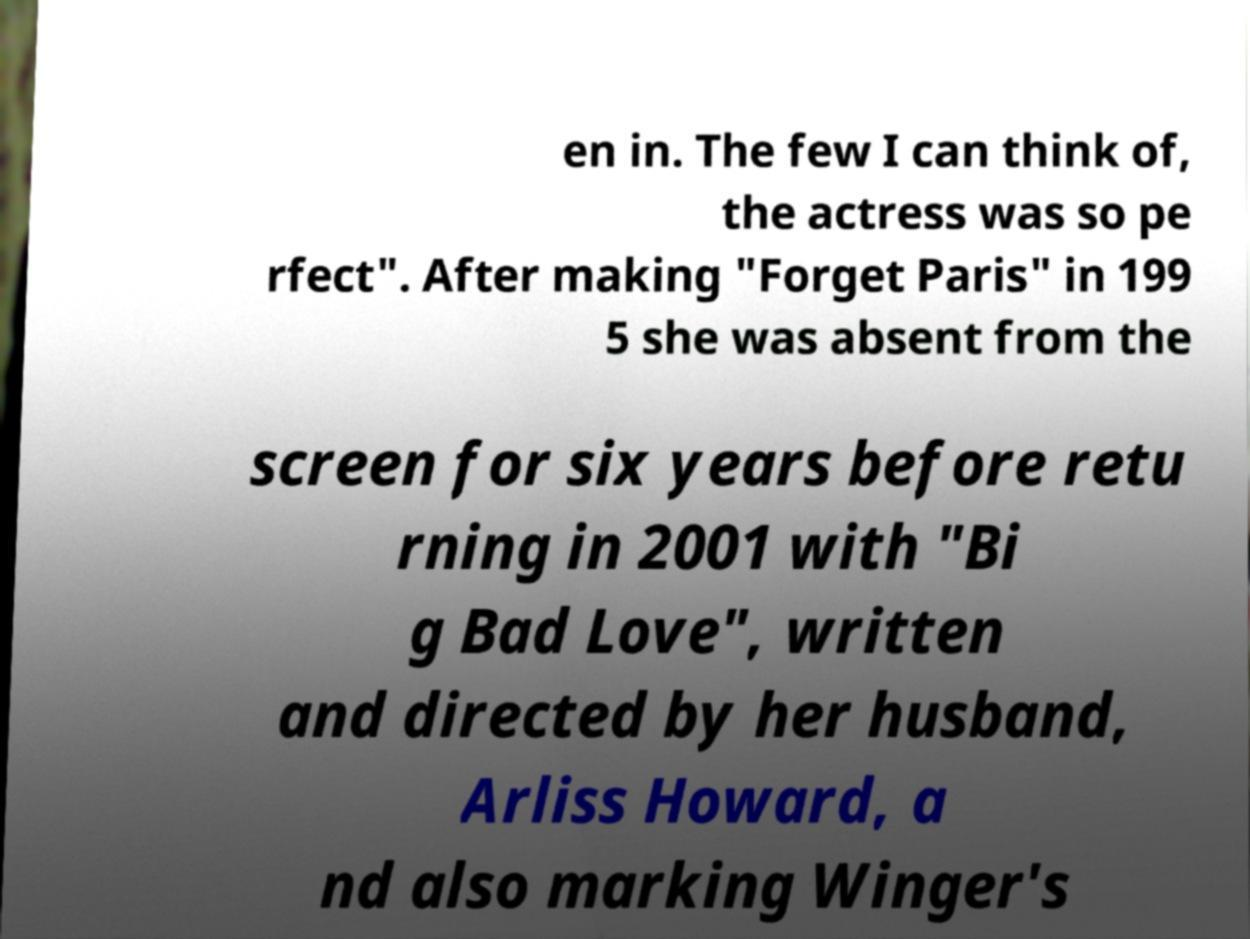For documentation purposes, I need the text within this image transcribed. Could you provide that? en in. The few I can think of, the actress was so pe rfect". After making "Forget Paris" in 199 5 she was absent from the screen for six years before retu rning in 2001 with "Bi g Bad Love", written and directed by her husband, Arliss Howard, a nd also marking Winger's 